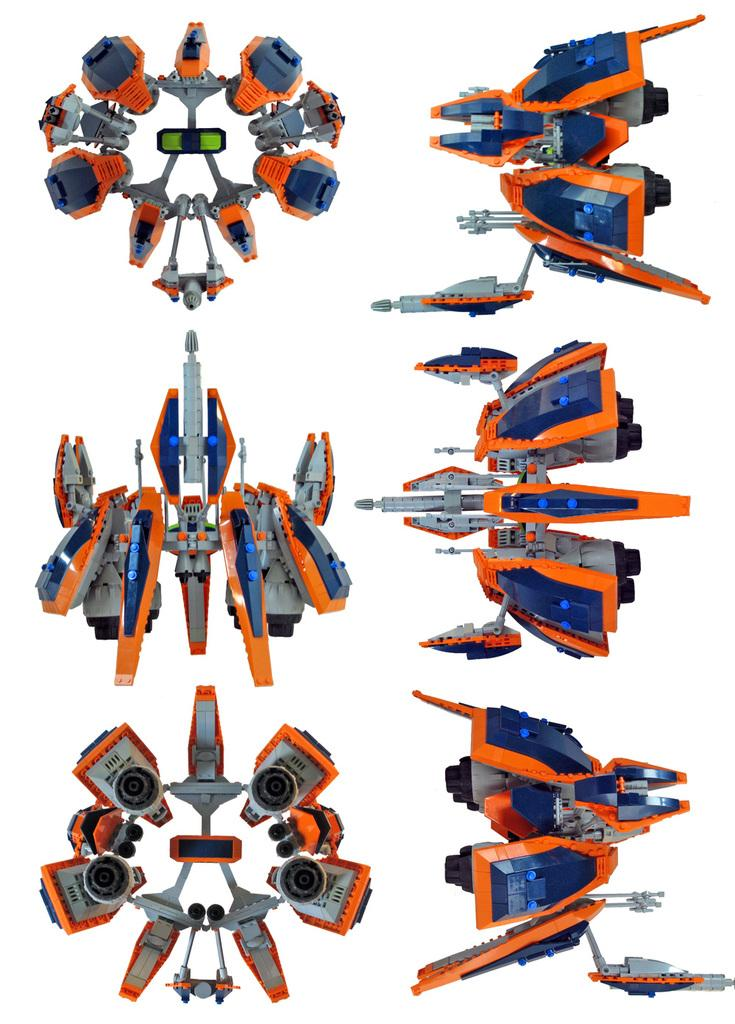What type of objects are present in the image? The image contains toys. What do the toys resemble? The toys resemble robots. What colors are the toys in the image? The toys are in blue and orange colors. What language do the toys speak in the image? The toys do not speak in the image, as they are inanimate objects. Can you see any leaves in the image? There are no leaves present in the image. 